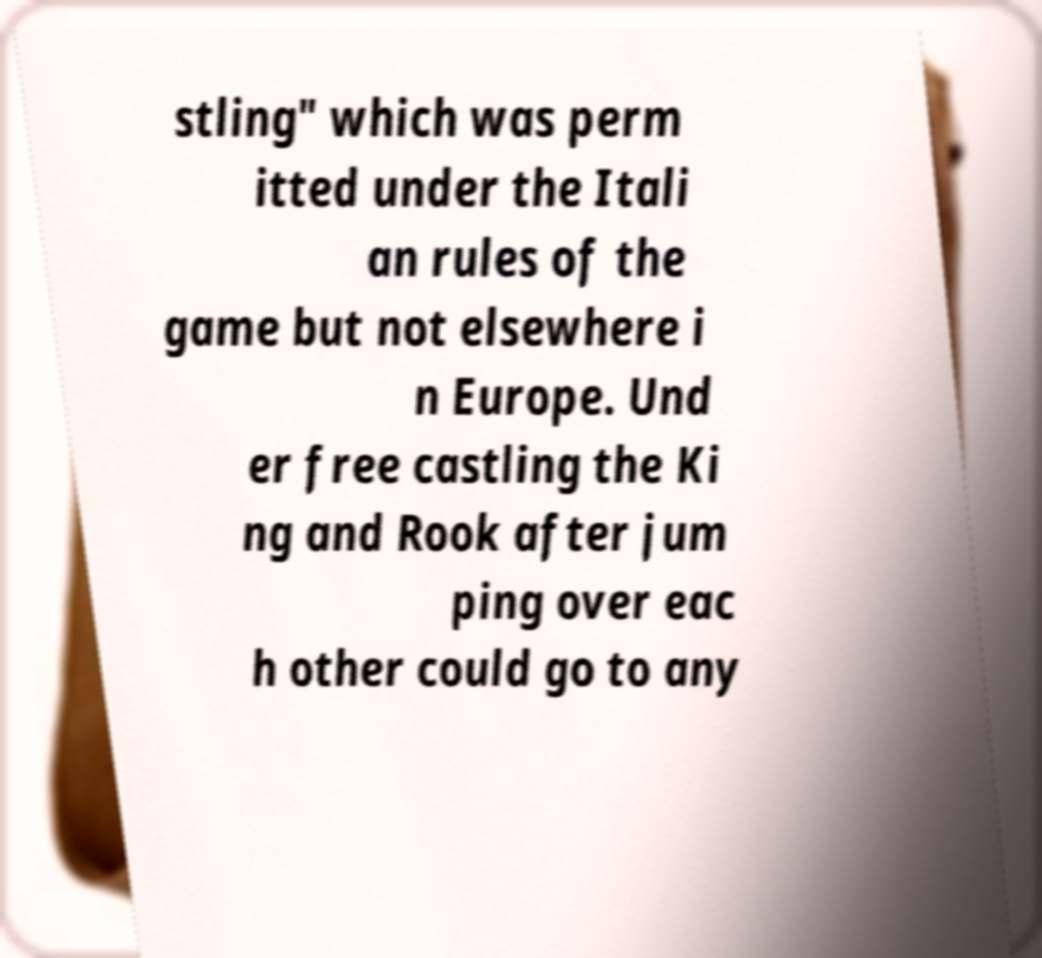Could you assist in decoding the text presented in this image and type it out clearly? stling" which was perm itted under the Itali an rules of the game but not elsewhere i n Europe. Und er free castling the Ki ng and Rook after jum ping over eac h other could go to any 